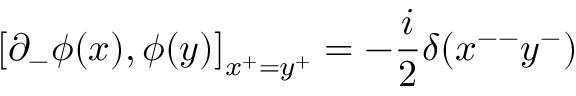<formula> <loc_0><loc_0><loc_500><loc_500>\left [ \partial _ { - } \phi ( x ) , \phi ( y ) \right ] _ { x ^ { + } = y ^ { + } } = - \frac { i } { 2 } \delta ( x ^ { - - } y ^ { - } )</formula> 